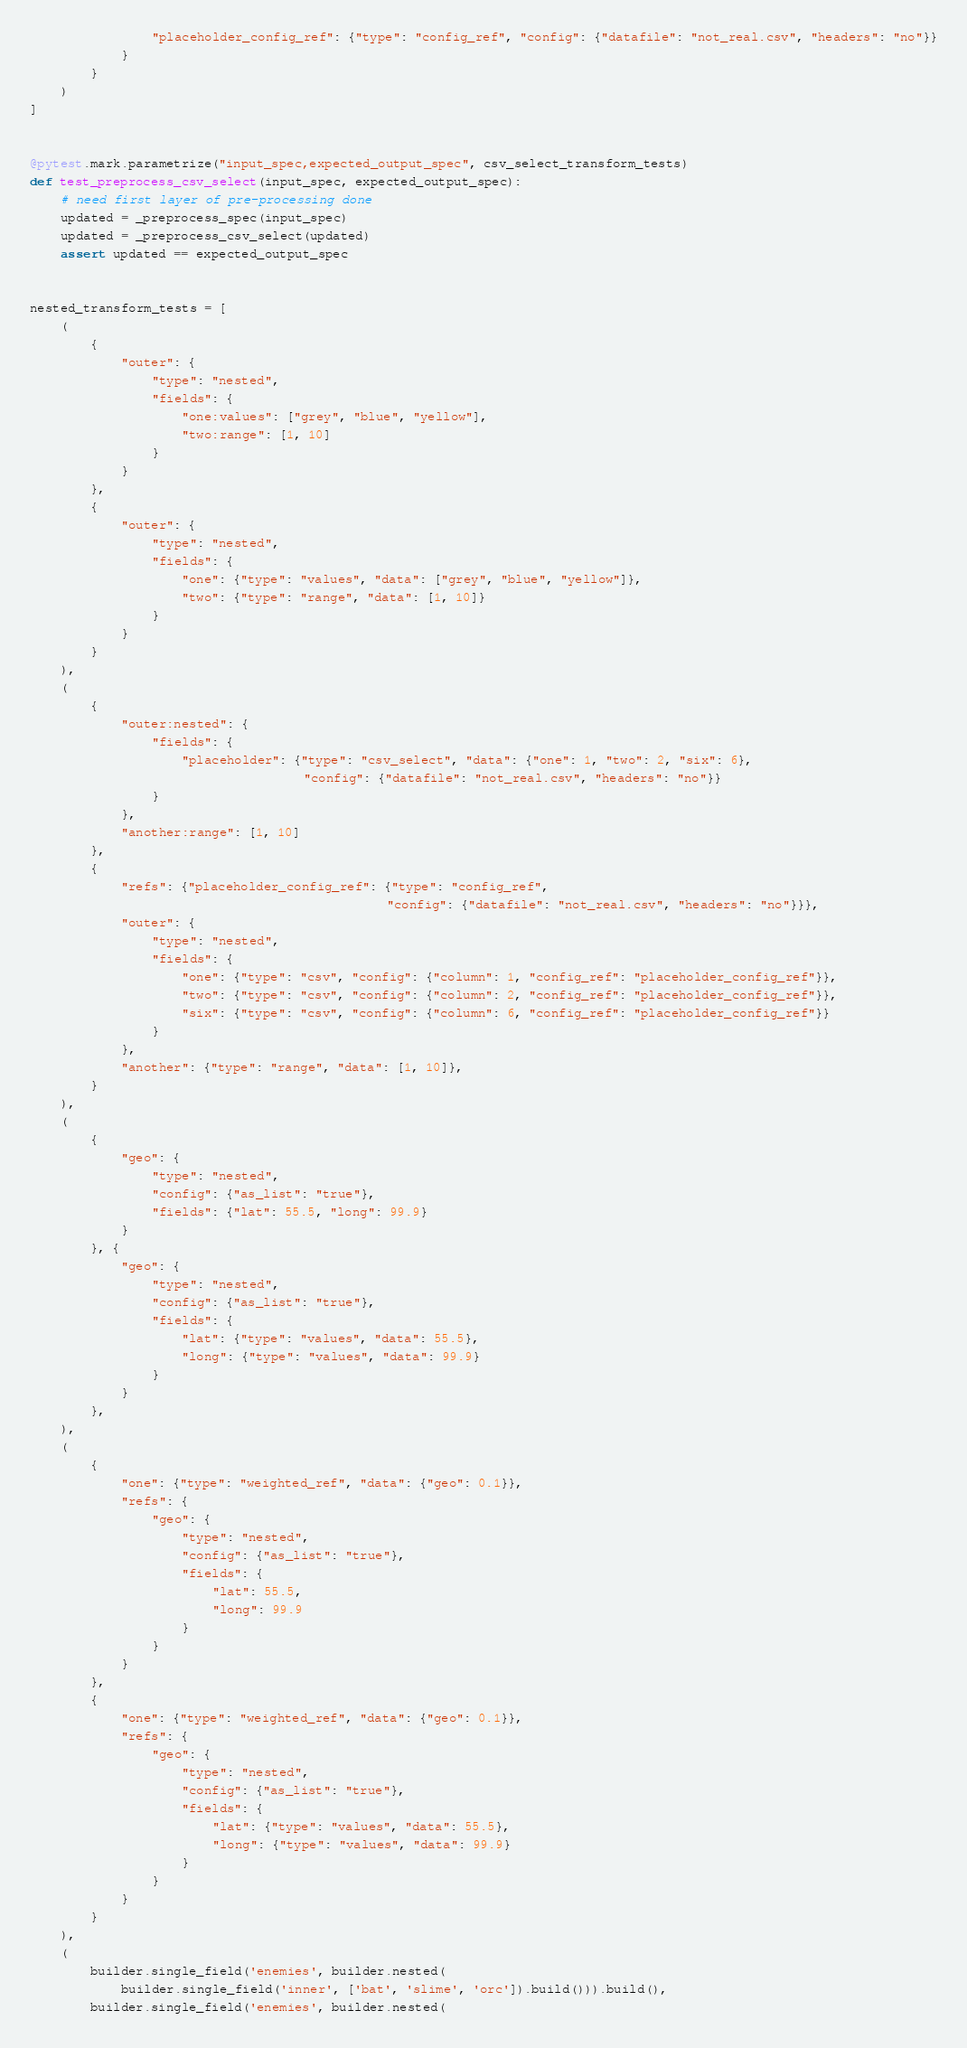Convert code to text. <code><loc_0><loc_0><loc_500><loc_500><_Python_>                "placeholder_config_ref": {"type": "config_ref", "config": {"datafile": "not_real.csv", "headers": "no"}}
            }
        }
    )
]


@pytest.mark.parametrize("input_spec,expected_output_spec", csv_select_transform_tests)
def test_preprocess_csv_select(input_spec, expected_output_spec):
    # need first layer of pre-processing done
    updated = _preprocess_spec(input_spec)
    updated = _preprocess_csv_select(updated)
    assert updated == expected_output_spec


nested_transform_tests = [
    (
        {
            "outer": {
                "type": "nested",
                "fields": {
                    "one:values": ["grey", "blue", "yellow"],
                    "two:range": [1, 10]
                }
            }
        },
        {
            "outer": {
                "type": "nested",
                "fields": {
                    "one": {"type": "values", "data": ["grey", "blue", "yellow"]},
                    "two": {"type": "range", "data": [1, 10]}
                }
            }
        }
    ),
    (
        {
            "outer:nested": {
                "fields": {
                    "placeholder": {"type": "csv_select", "data": {"one": 1, "two": 2, "six": 6},
                                    "config": {"datafile": "not_real.csv", "headers": "no"}}
                }
            },
            "another:range": [1, 10]
        },
        {
            "refs": {"placeholder_config_ref": {"type": "config_ref",
                                               "config": {"datafile": "not_real.csv", "headers": "no"}}},
            "outer": {
                "type": "nested",
                "fields": {
                    "one": {"type": "csv", "config": {"column": 1, "config_ref": "placeholder_config_ref"}},
                    "two": {"type": "csv", "config": {"column": 2, "config_ref": "placeholder_config_ref"}},
                    "six": {"type": "csv", "config": {"column": 6, "config_ref": "placeholder_config_ref"}}
                }
            },
            "another": {"type": "range", "data": [1, 10]},
        }
    ),
    (
        {
            "geo": {
                "type": "nested",
                "config": {"as_list": "true"},
                "fields": {"lat": 55.5, "long": 99.9}
            }
        }, {
            "geo": {
                "type": "nested",
                "config": {"as_list": "true"},
                "fields": {
                    "lat": {"type": "values", "data": 55.5},
                    "long": {"type": "values", "data": 99.9}
                }
            }
        },
    ),
    (
        {
            "one": {"type": "weighted_ref", "data": {"geo": 0.1}},
            "refs": {
                "geo": {
                    "type": "nested",
                    "config": {"as_list": "true"},
                    "fields": {
                        "lat": 55.5,
                        "long": 99.9
                    }
                }
            }
        },
        {
            "one": {"type": "weighted_ref", "data": {"geo": 0.1}},
            "refs": {
                "geo": {
                    "type": "nested",
                    "config": {"as_list": "true"},
                    "fields": {
                        "lat": {"type": "values", "data": 55.5},
                        "long": {"type": "values", "data": 99.9}
                    }
                }
            }
        }
    ),
    (
        builder.single_field('enemies', builder.nested(
            builder.single_field('inner', ['bat', 'slime', 'orc']).build())).build(),
        builder.single_field('enemies', builder.nested(</code> 